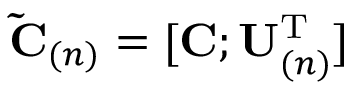<formula> <loc_0><loc_0><loc_500><loc_500>\tilde { C } _ { ( n ) } = [ C ; U _ { ( n ) } ^ { T } ]</formula> 